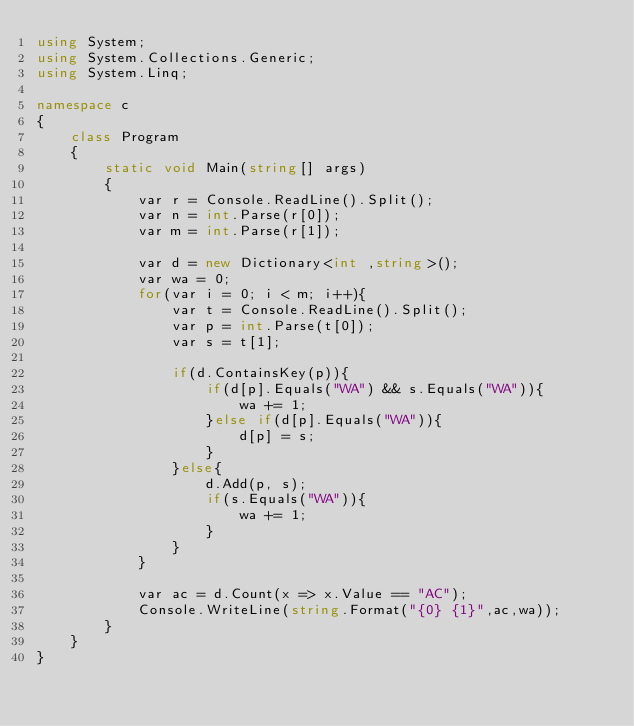<code> <loc_0><loc_0><loc_500><loc_500><_C#_>using System;
using System.Collections.Generic;
using System.Linq;

namespace c
{
    class Program
    {
        static void Main(string[] args)
        {
            var r = Console.ReadLine().Split();
            var n = int.Parse(r[0]);
            var m = int.Parse(r[1]);

            var d = new Dictionary<int ,string>();
            var wa = 0;
            for(var i = 0; i < m; i++){
                var t = Console.ReadLine().Split();
                var p = int.Parse(t[0]);
                var s = t[1];

                if(d.ContainsKey(p)){                    
                    if(d[p].Equals("WA") && s.Equals("WA")){
                        wa += 1;
                    }else if(d[p].Equals("WA")){
                        d[p] = s;
                    }
                }else{
                    d.Add(p, s);
                    if(s.Equals("WA")){
                        wa += 1;
                    }                    
                }
            }

            var ac = d.Count(x => x.Value == "AC");
            Console.WriteLine(string.Format("{0} {1}",ac,wa));
        }
    }
}
</code> 